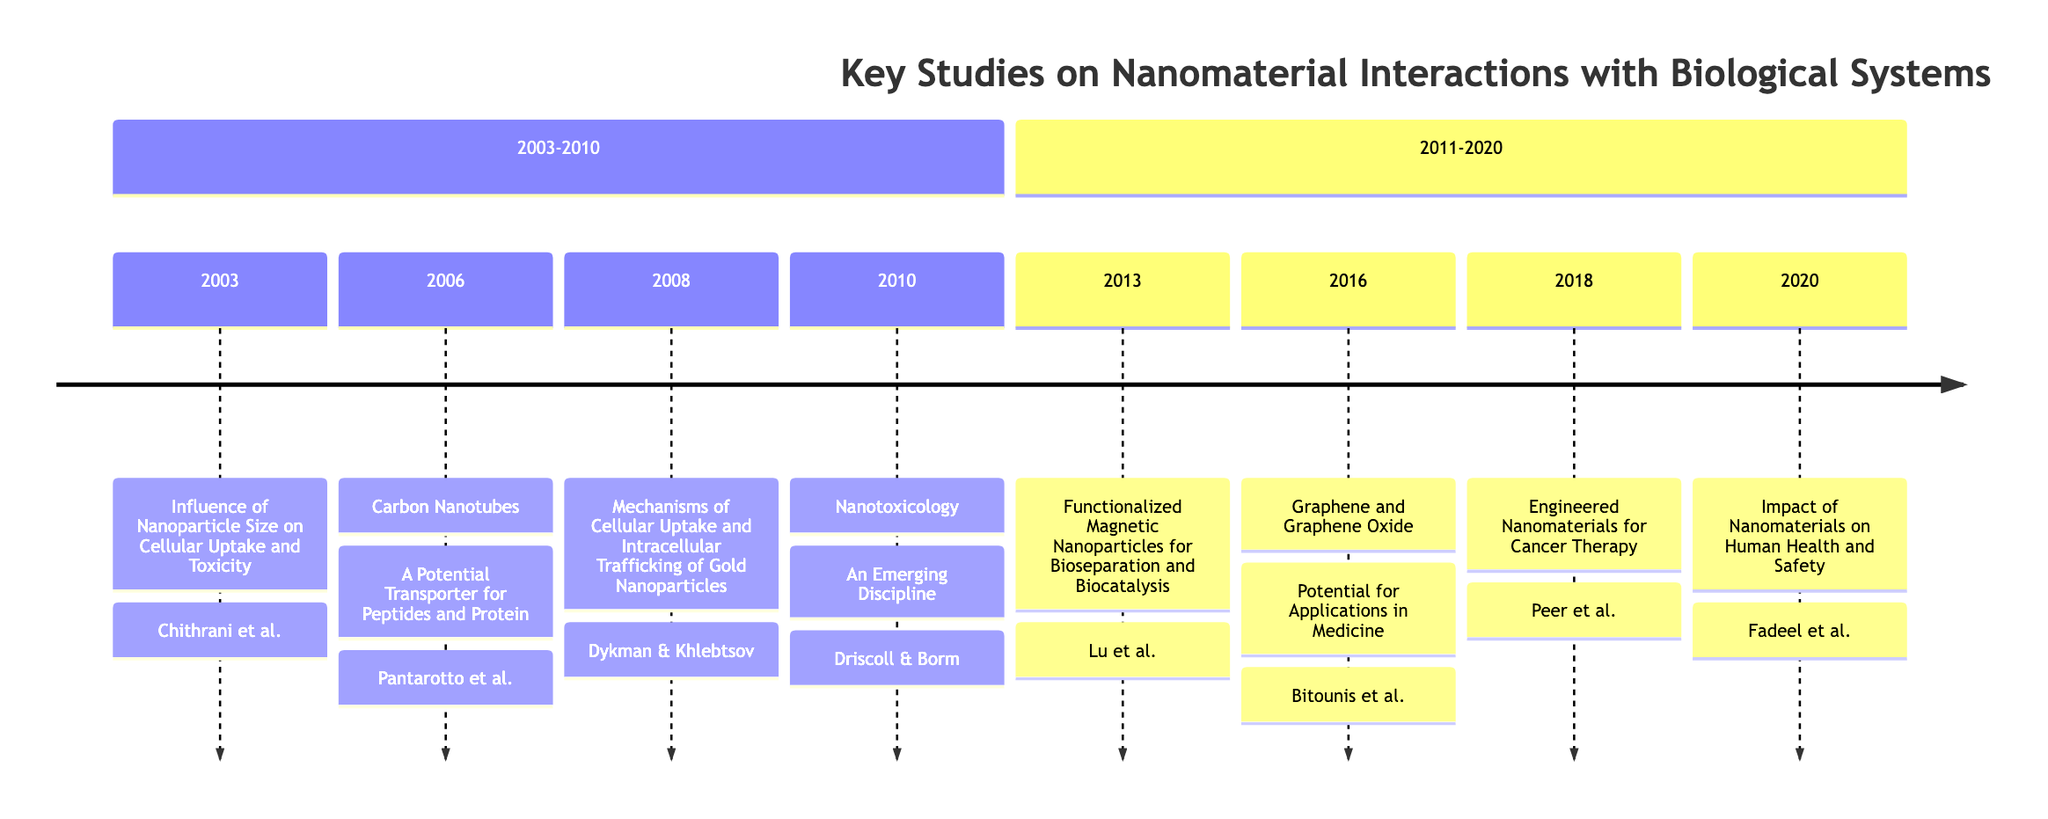What study was published in 2003? The diagram indicates that in 2003, the study titled "Influence of Nanoparticle Size on Cellular Uptake and Toxicity" was conducted.
Answer: Influence of Nanoparticle Size on Cellular Uptake and Toxicity Who are the researchers of the study in 2006? Referring to the 2006 entry, the researchers are listed as Pantarotto, D., Bianco, A., Prato, M.
Answer: Pantarotto, D., Bianco, A., Prato, M What is the focus of the study conducted in 2016? In 2016, the focus of the study is on "Graphene and Graphene Oxide: Potential for Applications in Medicine," highlighting their biocompatibility and versatility in medical applications.
Answer: Graphene and Graphene Oxide: Potential for Applications in Medicine How many studies are listed between 2003 and 2010? By counting the studies from the years 2003 to 2010, there are four studies total.
Answer: 4 Which journal published the study by Dykman and Khlebtsov? The diagram shows that the study titled "Mechanisms of Cellular Uptake and Intracellular Trafficking of Gold Nanoparticles" by Dykman and Khlebtsov was published in "Chemical Society Reviews."
Answer: Chemical Society Reviews In which year was nanotoxicology formally introduced as a field? The timeline clearly states that nanotoxicology was formally introduced as a discipline in the year 2010.
Answer: 2010 What common theme can be observed in studies conducted post-2010? The studies post-2010 commonly focus on the applications of engineered nanomaterials in healthcare and their biological impacts, particularly in areas like cancer therapy and health safety.
Answer: Applications in healthcare Name one type of nanoparticle discussed in the 2018 study. The 2018 study titled "Engineered Nanomaterials for Cancer Therapy" discusses various types, including liposomes and dendrimers.
Answer: Liposomes Which year marks the latest study in the timeline? Looking at the entries, the most recent study listed is from the year 2020.
Answer: 2020 